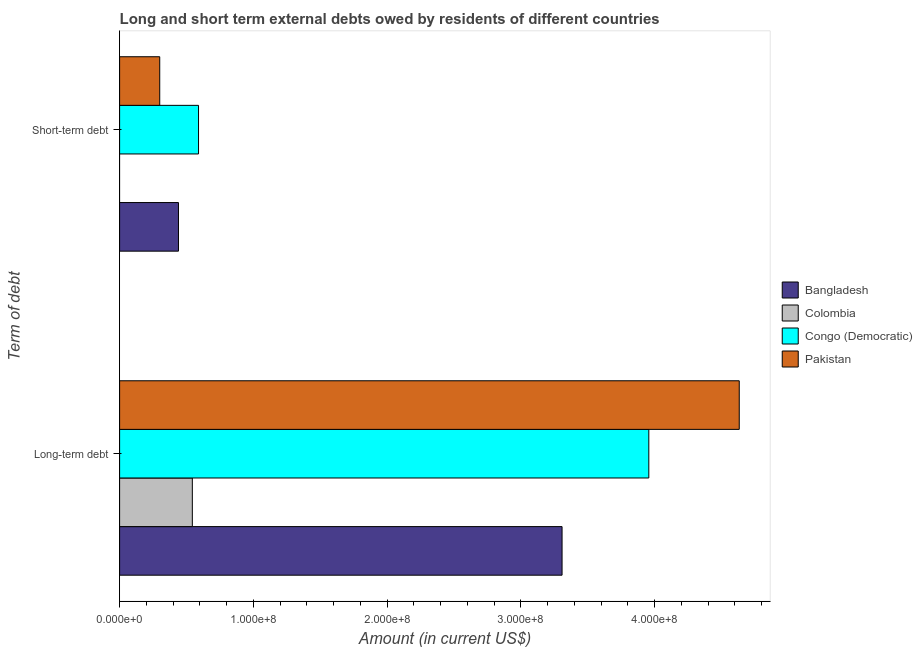How many different coloured bars are there?
Provide a succinct answer. 4. Are the number of bars per tick equal to the number of legend labels?
Provide a short and direct response. No. What is the label of the 1st group of bars from the top?
Offer a terse response. Short-term debt. What is the long-term debts owed by residents in Colombia?
Your response must be concise. 5.44e+07. Across all countries, what is the maximum short-term debts owed by residents?
Your answer should be very brief. 5.90e+07. Across all countries, what is the minimum long-term debts owed by residents?
Make the answer very short. 5.44e+07. In which country was the long-term debts owed by residents maximum?
Give a very brief answer. Pakistan. What is the total long-term debts owed by residents in the graph?
Your answer should be very brief. 1.24e+09. What is the difference between the long-term debts owed by residents in Congo (Democratic) and that in Colombia?
Ensure brevity in your answer.  3.41e+08. What is the difference between the short-term debts owed by residents in Bangladesh and the long-term debts owed by residents in Colombia?
Your response must be concise. -1.04e+07. What is the average long-term debts owed by residents per country?
Keep it short and to the point. 3.11e+08. What is the difference between the short-term debts owed by residents and long-term debts owed by residents in Bangladesh?
Offer a terse response. -2.87e+08. In how many countries, is the short-term debts owed by residents greater than 180000000 US$?
Offer a very short reply. 0. What is the ratio of the short-term debts owed by residents in Bangladesh to that in Pakistan?
Your answer should be compact. 1.47. Is the short-term debts owed by residents in Bangladesh less than that in Congo (Democratic)?
Your answer should be very brief. Yes. How many bars are there?
Give a very brief answer. 7. Are all the bars in the graph horizontal?
Provide a short and direct response. Yes. How many countries are there in the graph?
Keep it short and to the point. 4. What is the difference between two consecutive major ticks on the X-axis?
Keep it short and to the point. 1.00e+08. Are the values on the major ticks of X-axis written in scientific E-notation?
Give a very brief answer. Yes. Does the graph contain any zero values?
Provide a succinct answer. Yes. Where does the legend appear in the graph?
Provide a succinct answer. Center right. How many legend labels are there?
Offer a very short reply. 4. How are the legend labels stacked?
Your answer should be compact. Vertical. What is the title of the graph?
Keep it short and to the point. Long and short term external debts owed by residents of different countries. What is the label or title of the Y-axis?
Your answer should be compact. Term of debt. What is the Amount (in current US$) of Bangladesh in Long-term debt?
Ensure brevity in your answer.  3.31e+08. What is the Amount (in current US$) of Colombia in Long-term debt?
Your response must be concise. 5.44e+07. What is the Amount (in current US$) of Congo (Democratic) in Long-term debt?
Provide a short and direct response. 3.96e+08. What is the Amount (in current US$) of Pakistan in Long-term debt?
Ensure brevity in your answer.  4.63e+08. What is the Amount (in current US$) of Bangladesh in Short-term debt?
Give a very brief answer. 4.40e+07. What is the Amount (in current US$) in Colombia in Short-term debt?
Your answer should be compact. 0. What is the Amount (in current US$) in Congo (Democratic) in Short-term debt?
Provide a succinct answer. 5.90e+07. What is the Amount (in current US$) of Pakistan in Short-term debt?
Your answer should be very brief. 3.00e+07. Across all Term of debt, what is the maximum Amount (in current US$) of Bangladesh?
Provide a short and direct response. 3.31e+08. Across all Term of debt, what is the maximum Amount (in current US$) of Colombia?
Ensure brevity in your answer.  5.44e+07. Across all Term of debt, what is the maximum Amount (in current US$) in Congo (Democratic)?
Ensure brevity in your answer.  3.96e+08. Across all Term of debt, what is the maximum Amount (in current US$) of Pakistan?
Offer a very short reply. 4.63e+08. Across all Term of debt, what is the minimum Amount (in current US$) in Bangladesh?
Keep it short and to the point. 4.40e+07. Across all Term of debt, what is the minimum Amount (in current US$) in Colombia?
Offer a very short reply. 0. Across all Term of debt, what is the minimum Amount (in current US$) of Congo (Democratic)?
Your answer should be very brief. 5.90e+07. Across all Term of debt, what is the minimum Amount (in current US$) in Pakistan?
Provide a short and direct response. 3.00e+07. What is the total Amount (in current US$) in Bangladesh in the graph?
Ensure brevity in your answer.  3.75e+08. What is the total Amount (in current US$) of Colombia in the graph?
Provide a succinct answer. 5.44e+07. What is the total Amount (in current US$) in Congo (Democratic) in the graph?
Offer a terse response. 4.55e+08. What is the total Amount (in current US$) in Pakistan in the graph?
Your answer should be very brief. 4.93e+08. What is the difference between the Amount (in current US$) in Bangladesh in Long-term debt and that in Short-term debt?
Keep it short and to the point. 2.87e+08. What is the difference between the Amount (in current US$) in Congo (Democratic) in Long-term debt and that in Short-term debt?
Keep it short and to the point. 3.37e+08. What is the difference between the Amount (in current US$) in Pakistan in Long-term debt and that in Short-term debt?
Give a very brief answer. 4.33e+08. What is the difference between the Amount (in current US$) in Bangladesh in Long-term debt and the Amount (in current US$) in Congo (Democratic) in Short-term debt?
Ensure brevity in your answer.  2.72e+08. What is the difference between the Amount (in current US$) in Bangladesh in Long-term debt and the Amount (in current US$) in Pakistan in Short-term debt?
Offer a terse response. 3.01e+08. What is the difference between the Amount (in current US$) of Colombia in Long-term debt and the Amount (in current US$) of Congo (Democratic) in Short-term debt?
Provide a short and direct response. -4.64e+06. What is the difference between the Amount (in current US$) in Colombia in Long-term debt and the Amount (in current US$) in Pakistan in Short-term debt?
Make the answer very short. 2.44e+07. What is the difference between the Amount (in current US$) of Congo (Democratic) in Long-term debt and the Amount (in current US$) of Pakistan in Short-term debt?
Give a very brief answer. 3.66e+08. What is the average Amount (in current US$) of Bangladesh per Term of debt?
Your response must be concise. 1.87e+08. What is the average Amount (in current US$) in Colombia per Term of debt?
Your response must be concise. 2.72e+07. What is the average Amount (in current US$) in Congo (Democratic) per Term of debt?
Give a very brief answer. 2.27e+08. What is the average Amount (in current US$) of Pakistan per Term of debt?
Ensure brevity in your answer.  2.47e+08. What is the difference between the Amount (in current US$) in Bangladesh and Amount (in current US$) in Colombia in Long-term debt?
Your answer should be compact. 2.76e+08. What is the difference between the Amount (in current US$) in Bangladesh and Amount (in current US$) in Congo (Democratic) in Long-term debt?
Your answer should be compact. -6.49e+07. What is the difference between the Amount (in current US$) in Bangladesh and Amount (in current US$) in Pakistan in Long-term debt?
Provide a short and direct response. -1.32e+08. What is the difference between the Amount (in current US$) in Colombia and Amount (in current US$) in Congo (Democratic) in Long-term debt?
Ensure brevity in your answer.  -3.41e+08. What is the difference between the Amount (in current US$) of Colombia and Amount (in current US$) of Pakistan in Long-term debt?
Your response must be concise. -4.09e+08. What is the difference between the Amount (in current US$) in Congo (Democratic) and Amount (in current US$) in Pakistan in Long-term debt?
Make the answer very short. -6.76e+07. What is the difference between the Amount (in current US$) of Bangladesh and Amount (in current US$) of Congo (Democratic) in Short-term debt?
Offer a very short reply. -1.50e+07. What is the difference between the Amount (in current US$) in Bangladesh and Amount (in current US$) in Pakistan in Short-term debt?
Make the answer very short. 1.40e+07. What is the difference between the Amount (in current US$) in Congo (Democratic) and Amount (in current US$) in Pakistan in Short-term debt?
Offer a terse response. 2.90e+07. What is the ratio of the Amount (in current US$) of Bangladesh in Long-term debt to that in Short-term debt?
Offer a terse response. 7.52. What is the ratio of the Amount (in current US$) of Congo (Democratic) in Long-term debt to that in Short-term debt?
Offer a very short reply. 6.71. What is the ratio of the Amount (in current US$) of Pakistan in Long-term debt to that in Short-term debt?
Keep it short and to the point. 15.44. What is the difference between the highest and the second highest Amount (in current US$) in Bangladesh?
Offer a very short reply. 2.87e+08. What is the difference between the highest and the second highest Amount (in current US$) in Congo (Democratic)?
Offer a very short reply. 3.37e+08. What is the difference between the highest and the second highest Amount (in current US$) in Pakistan?
Keep it short and to the point. 4.33e+08. What is the difference between the highest and the lowest Amount (in current US$) of Bangladesh?
Your answer should be very brief. 2.87e+08. What is the difference between the highest and the lowest Amount (in current US$) in Colombia?
Provide a succinct answer. 5.44e+07. What is the difference between the highest and the lowest Amount (in current US$) of Congo (Democratic)?
Offer a very short reply. 3.37e+08. What is the difference between the highest and the lowest Amount (in current US$) of Pakistan?
Your response must be concise. 4.33e+08. 